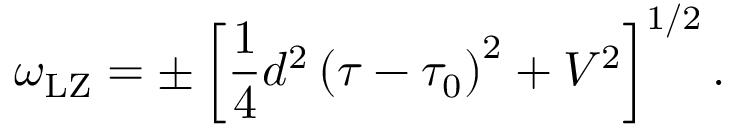Convert formula to latex. <formula><loc_0><loc_0><loc_500><loc_500>\omega _ { L Z } = \pm \left [ \frac { 1 } { 4 } d ^ { 2 } \left ( \tau - \tau _ { 0 } \right ) ^ { 2 } + V ^ { 2 } \right ] ^ { 1 / 2 } .</formula> 